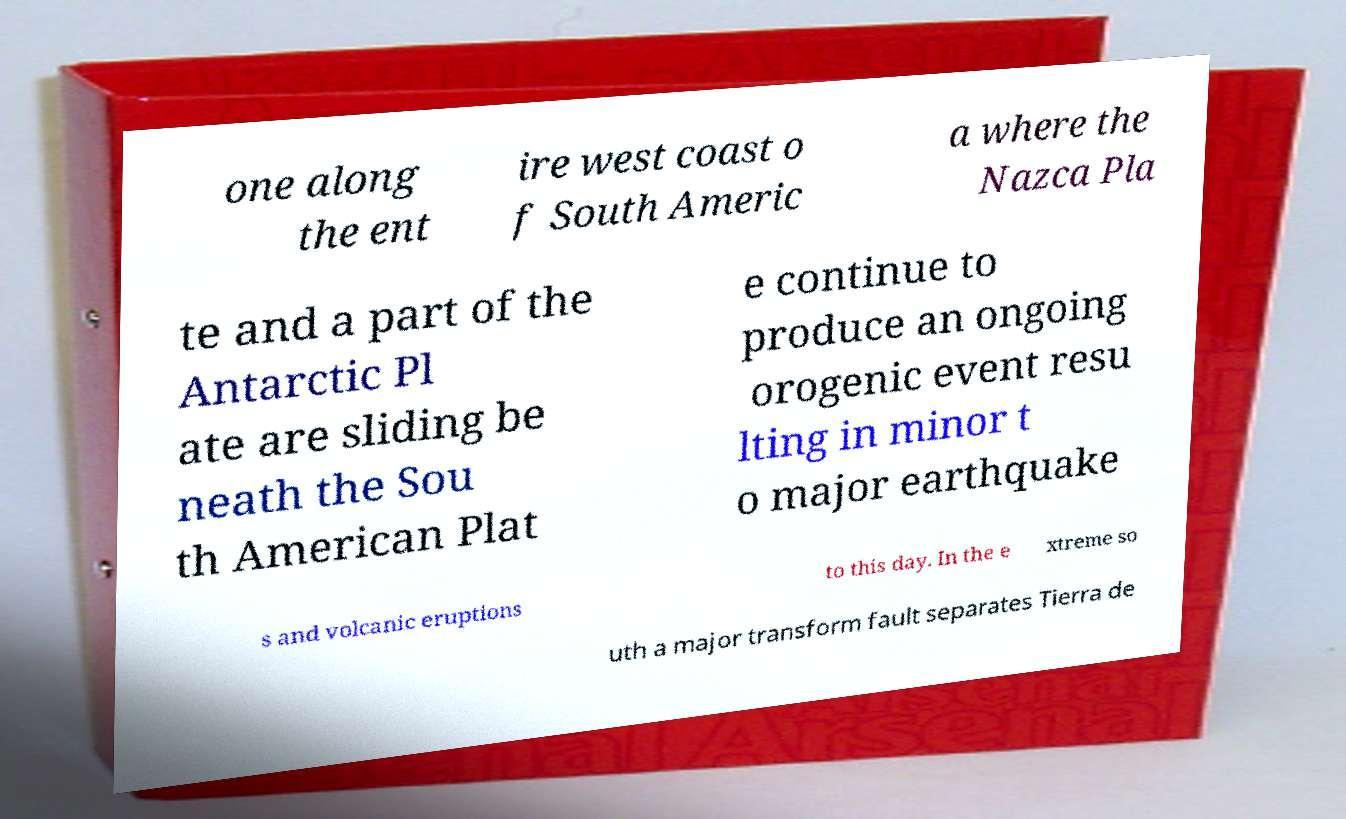What messages or text are displayed in this image? I need them in a readable, typed format. one along the ent ire west coast o f South Americ a where the Nazca Pla te and a part of the Antarctic Pl ate are sliding be neath the Sou th American Plat e continue to produce an ongoing orogenic event resu lting in minor t o major earthquake s and volcanic eruptions to this day. In the e xtreme so uth a major transform fault separates Tierra de 